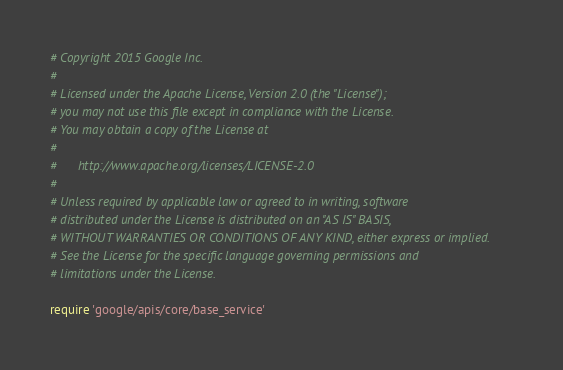<code> <loc_0><loc_0><loc_500><loc_500><_Ruby_># Copyright 2015 Google Inc.
#
# Licensed under the Apache License, Version 2.0 (the "License");
# you may not use this file except in compliance with the License.
# You may obtain a copy of the License at
#
#      http://www.apache.org/licenses/LICENSE-2.0
#
# Unless required by applicable law or agreed to in writing, software
# distributed under the License is distributed on an "AS IS" BASIS,
# WITHOUT WARRANTIES OR CONDITIONS OF ANY KIND, either express or implied.
# See the License for the specific language governing permissions and
# limitations under the License.

require 'google/apis/core/base_service'</code> 